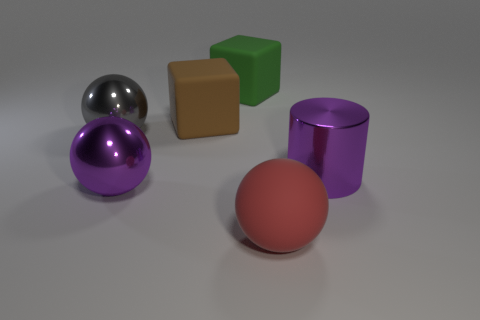Subtract all brown balls. Subtract all cyan cubes. How many balls are left? 3 Add 1 large purple balls. How many objects exist? 7 Subtract all blocks. How many objects are left? 4 Add 3 red rubber balls. How many red rubber balls exist? 4 Subtract 0 cyan spheres. How many objects are left? 6 Subtract all large brown blocks. Subtract all big brown matte things. How many objects are left? 4 Add 5 big gray objects. How many big gray objects are left? 6 